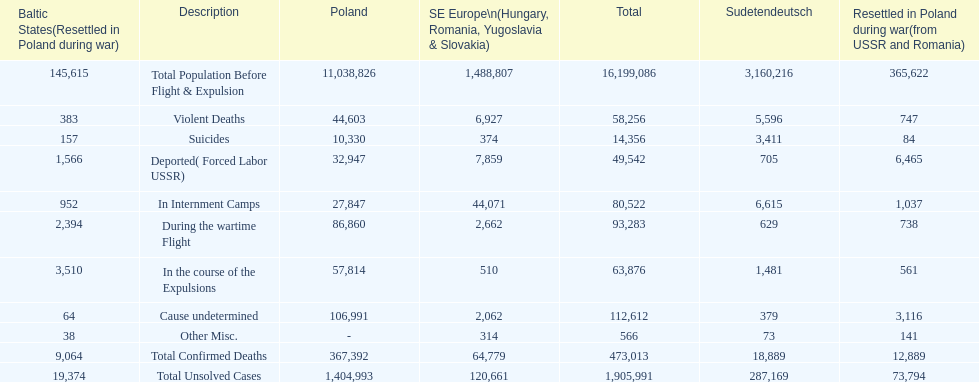What is the total of deaths in internment camps and during the wartime flight? 173,805. 